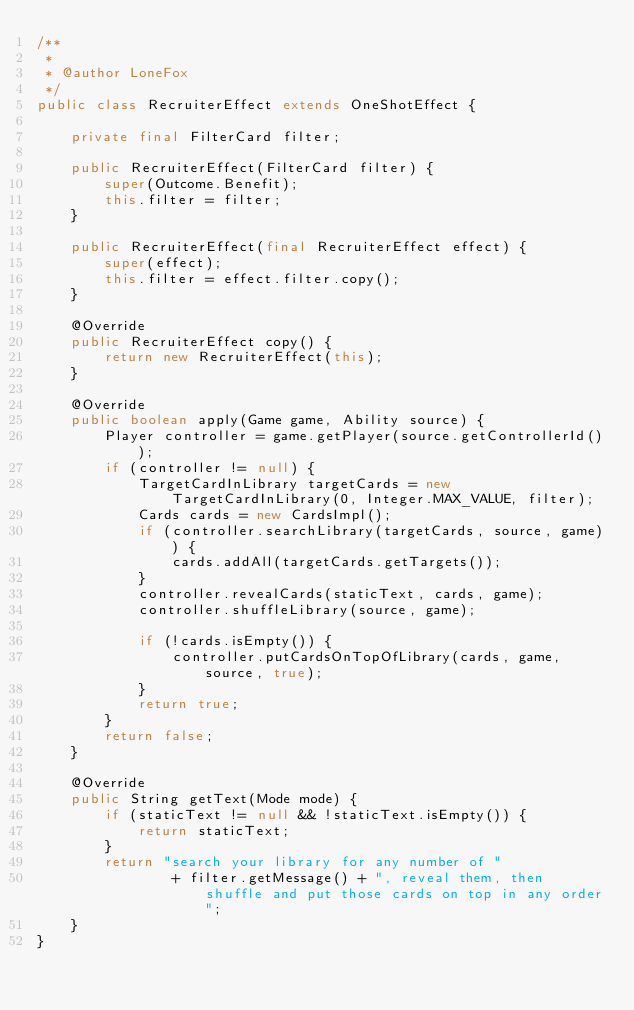<code> <loc_0><loc_0><loc_500><loc_500><_Java_>/**
 *
 * @author LoneFox
 */
public class RecruiterEffect extends OneShotEffect {

    private final FilterCard filter;

    public RecruiterEffect(FilterCard filter) {
        super(Outcome.Benefit);
        this.filter = filter;
    }

    public RecruiterEffect(final RecruiterEffect effect) {
        super(effect);
        this.filter = effect.filter.copy();
    }

    @Override
    public RecruiterEffect copy() {
        return new RecruiterEffect(this);
    }

    @Override
    public boolean apply(Game game, Ability source) {
        Player controller = game.getPlayer(source.getControllerId());
        if (controller != null) {
            TargetCardInLibrary targetCards = new TargetCardInLibrary(0, Integer.MAX_VALUE, filter);
            Cards cards = new CardsImpl();
            if (controller.searchLibrary(targetCards, source, game)) {
                cards.addAll(targetCards.getTargets());
            }
            controller.revealCards(staticText, cards, game);
            controller.shuffleLibrary(source, game);

            if (!cards.isEmpty()) {
                controller.putCardsOnTopOfLibrary(cards, game, source, true);
            }
            return true;
        }
        return false;
    }

    @Override
    public String getText(Mode mode) {
        if (staticText != null && !staticText.isEmpty()) {
            return staticText;
        }
        return "search your library for any number of "
                + filter.getMessage() + ", reveal them, then shuffle and put those cards on top in any order";
    }
}
</code> 